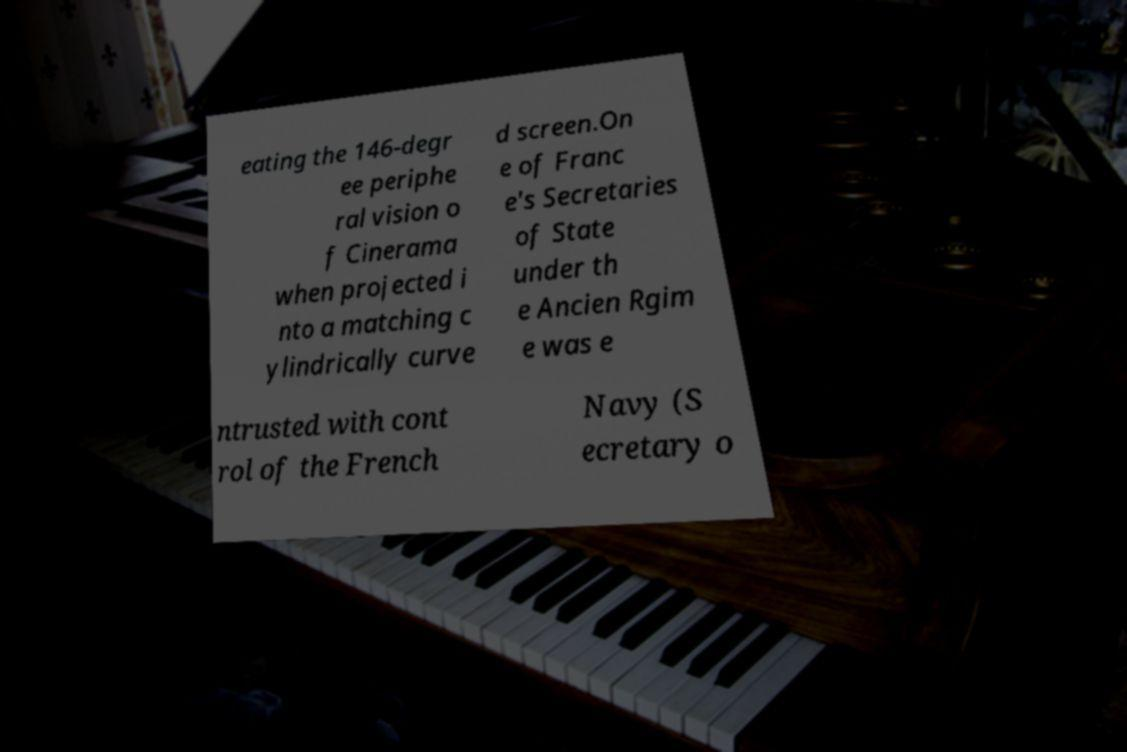Please read and relay the text visible in this image. What does it say? eating the 146-degr ee periphe ral vision o f Cinerama when projected i nto a matching c ylindrically curve d screen.On e of Franc e's Secretaries of State under th e Ancien Rgim e was e ntrusted with cont rol of the French Navy (S ecretary o 